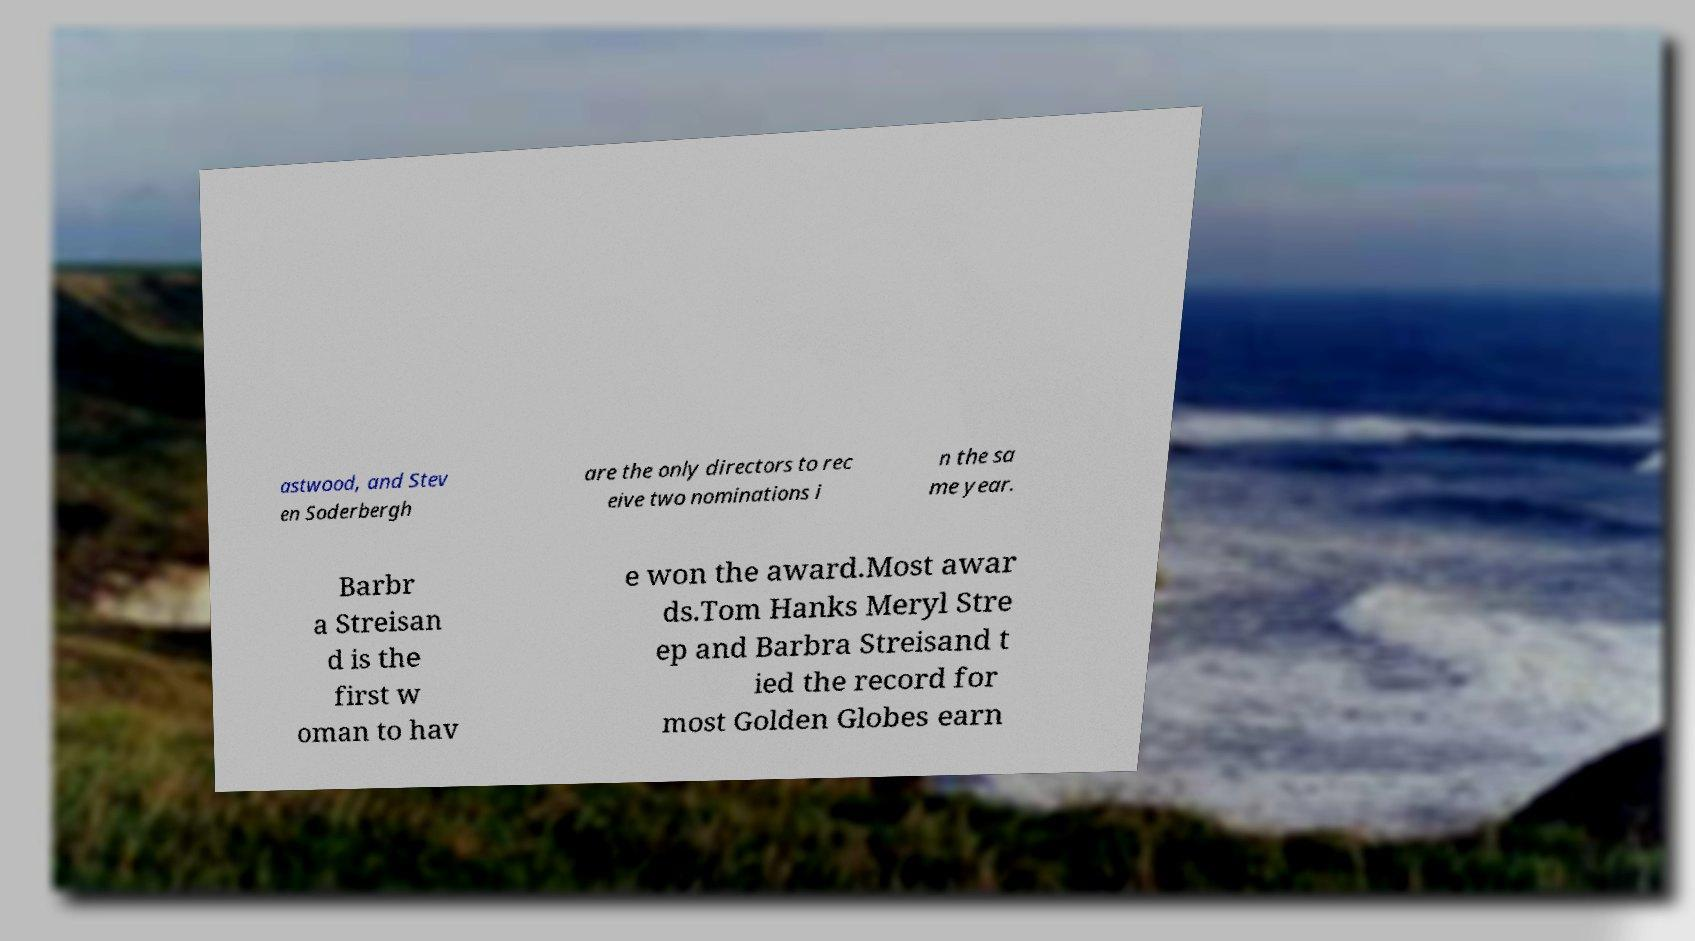Can you accurately transcribe the text from the provided image for me? astwood, and Stev en Soderbergh are the only directors to rec eive two nominations i n the sa me year. Barbr a Streisan d is the first w oman to hav e won the award.Most awar ds.Tom Hanks Meryl Stre ep and Barbra Streisand t ied the record for most Golden Globes earn 